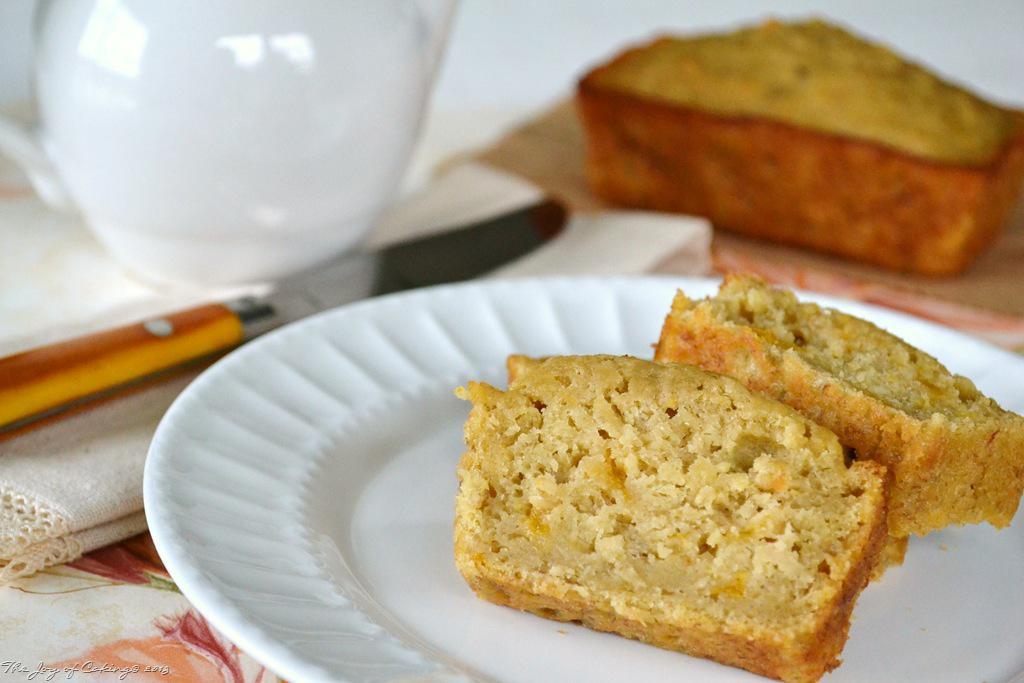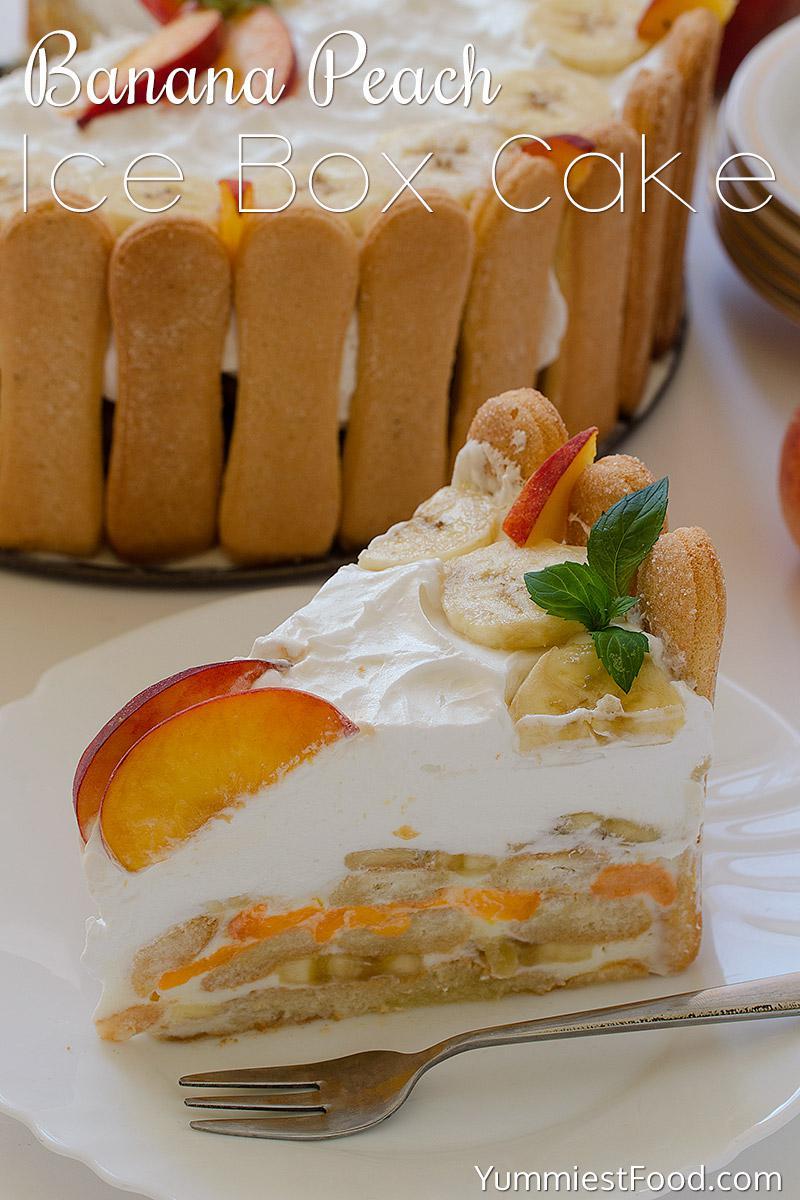The first image is the image on the left, the second image is the image on the right. Considering the images on both sides, is "One image shows a plate of sliced desserts in front of an uncut loaf and next to a knife." valid? Answer yes or no. Yes. The first image is the image on the left, the second image is the image on the right. Assess this claim about the two images: "there is a cake with beaches on top and lady finger cookies around the outside". Correct or not? Answer yes or no. Yes. 